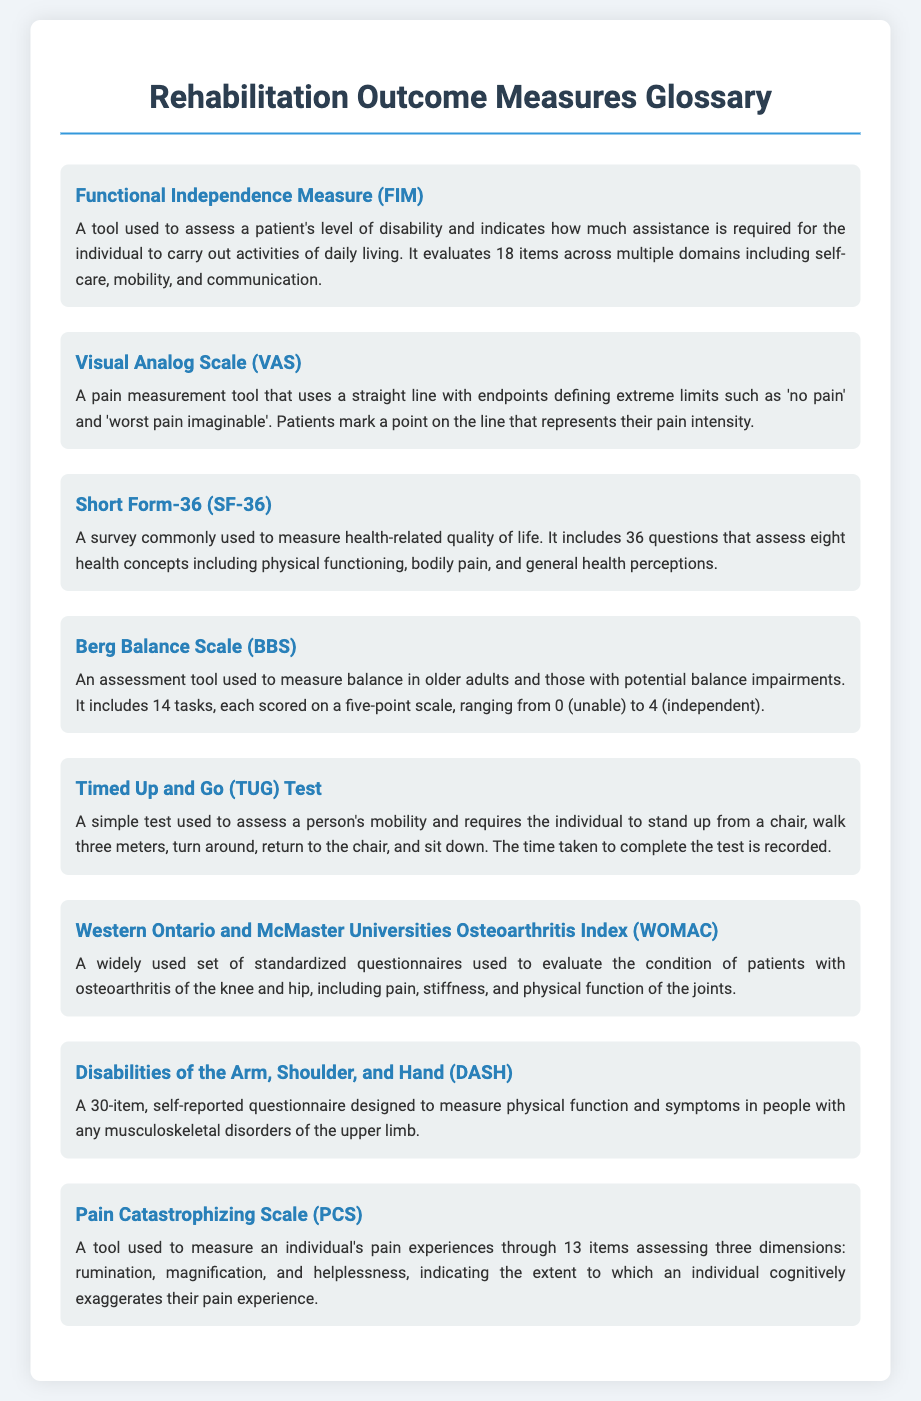What does FIM stand for? FIM is an abbreviation for Functional Independence Measure, used to assess a patient's level of disability.
Answer: Functional Independence Measure How many items are in the Short Form-36 survey? The Short Form-36 (SF-36) includes 36 questions assessing various health concepts.
Answer: 36 What scale is used in the Berg Balance Scale? The Berg Balance Scale (BBS) uses a five-point scale ranging from 0 to 4 to score performance on 14 tasks.
Answer: Five-point scale What does the Timed Up and Go (TUG) test assess? The TUG test is used to assess a person's mobility through a timed walking and standing task.
Answer: Mobility How many items are in the DASH questionnaire? The Disabilities of the Arm, Shoulder, and Hand (DASH) consists of 30 items to measure physical function and symptoms.
Answer: 30 Which tool measures pain catastrophizing? The Pain Catastrophizing Scale (PCS) is the tool specifically designed to measure an individual's pain experiences.
Answer: Pain Catastrophizing Scale What health conditions does WOMAC focus on? WOMAC focuses on evaluating patients with osteoarthritis of the knee and hip.
Answer: Osteoarthritis What are the three dimensions assessed by the PCS? The PCS assesses rumination, magnification, and helplessness regarding pain experiences.
Answer: Rumination, magnification, and helplessness What does the BBS consist of? The Berg Balance Scale (BBS) consists of 14 tasks that evaluate balance in older adults and those with balance impairments.
Answer: 14 tasks 